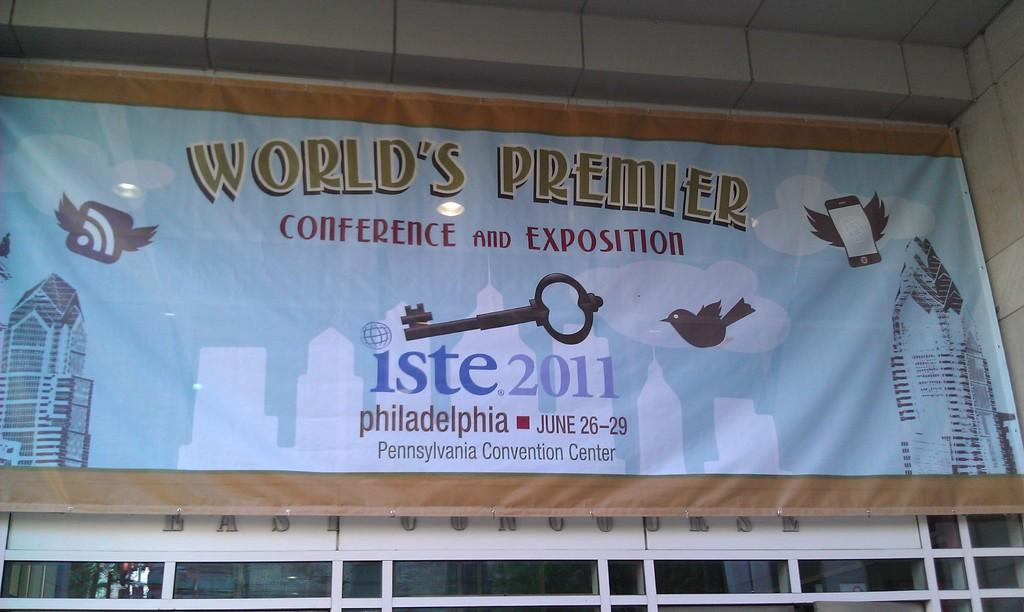<image>
Write a terse but informative summary of the picture. Banner on a buliding for "World's Premier Conference and Exposition". 